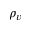<formula> <loc_0><loc_0><loc_500><loc_500>\rho _ { v }</formula> 